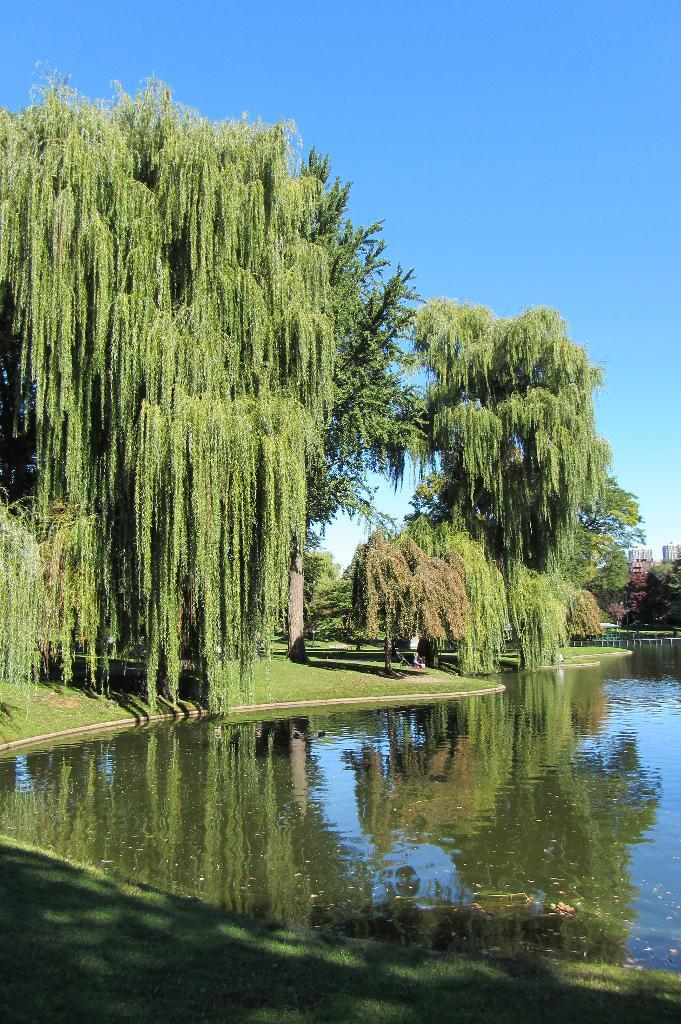What can be seen in the right corner of the image? There is water in the right corner of the image. What type of vegetation is present in the image? There are trees in the image. What is the ground made of where the trees are located? The trees are placed on a greenery ground. What can be seen in the distance in the image? There are buildings in the background of the image. What type of ink is used to draw the trees in the image? There is no indication that the trees in the image were drawn; they appear to be real trees. Can you see a knife being used in the image? There is no knife present in the image. 